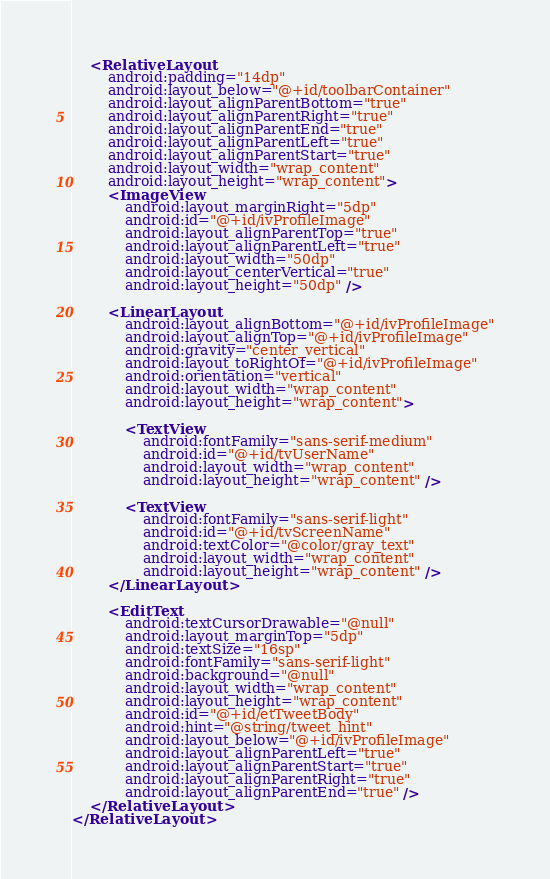<code> <loc_0><loc_0><loc_500><loc_500><_XML_>
    <RelativeLayout
        android:padding="14dp"
        android:layout_below="@+id/toolbarContainer"
        android:layout_alignParentBottom="true"
        android:layout_alignParentRight="true"
        android:layout_alignParentEnd="true"
        android:layout_alignParentLeft="true"
        android:layout_alignParentStart="true"
        android:layout_width="wrap_content"
        android:layout_height="wrap_content">
        <ImageView
            android:layout_marginRight="5dp"
            android:id="@+id/ivProfileImage"
            android:layout_alignParentTop="true"
            android:layout_alignParentLeft="true"
            android:layout_width="50dp"
            android:layout_centerVertical="true"
            android:layout_height="50dp" />

        <LinearLayout
            android:layout_alignBottom="@+id/ivProfileImage"
            android:layout_alignTop="@+id/ivProfileImage"
            android:gravity="center_vertical"
            android:layout_toRightOf="@+id/ivProfileImage"
            android:orientation="vertical"
            android:layout_width="wrap_content"
            android:layout_height="wrap_content">

            <TextView
                android:fontFamily="sans-serif-medium"
                android:id="@+id/tvUserName"
                android:layout_width="wrap_content"
                android:layout_height="wrap_content" />

            <TextView
                android:fontFamily="sans-serif-light"
                android:id="@+id/tvScreenName"
                android:textColor="@color/gray_text"
                android:layout_width="wrap_content"
                android:layout_height="wrap_content" />
        </LinearLayout>

        <EditText
            android:textCursorDrawable="@null"
            android:layout_marginTop="5dp"
            android:textSize="16sp"
            android:fontFamily="sans-serif-light"
            android:background="@null"
            android:layout_width="wrap_content"
            android:layout_height="wrap_content"
            android:id="@+id/etTweetBody"
            android:hint="@string/tweet_hint"
            android:layout_below="@+id/ivProfileImage"
            android:layout_alignParentLeft="true"
            android:layout_alignParentStart="true"
            android:layout_alignParentRight="true"
            android:layout_alignParentEnd="true" />
    </RelativeLayout>
</RelativeLayout>
</code> 